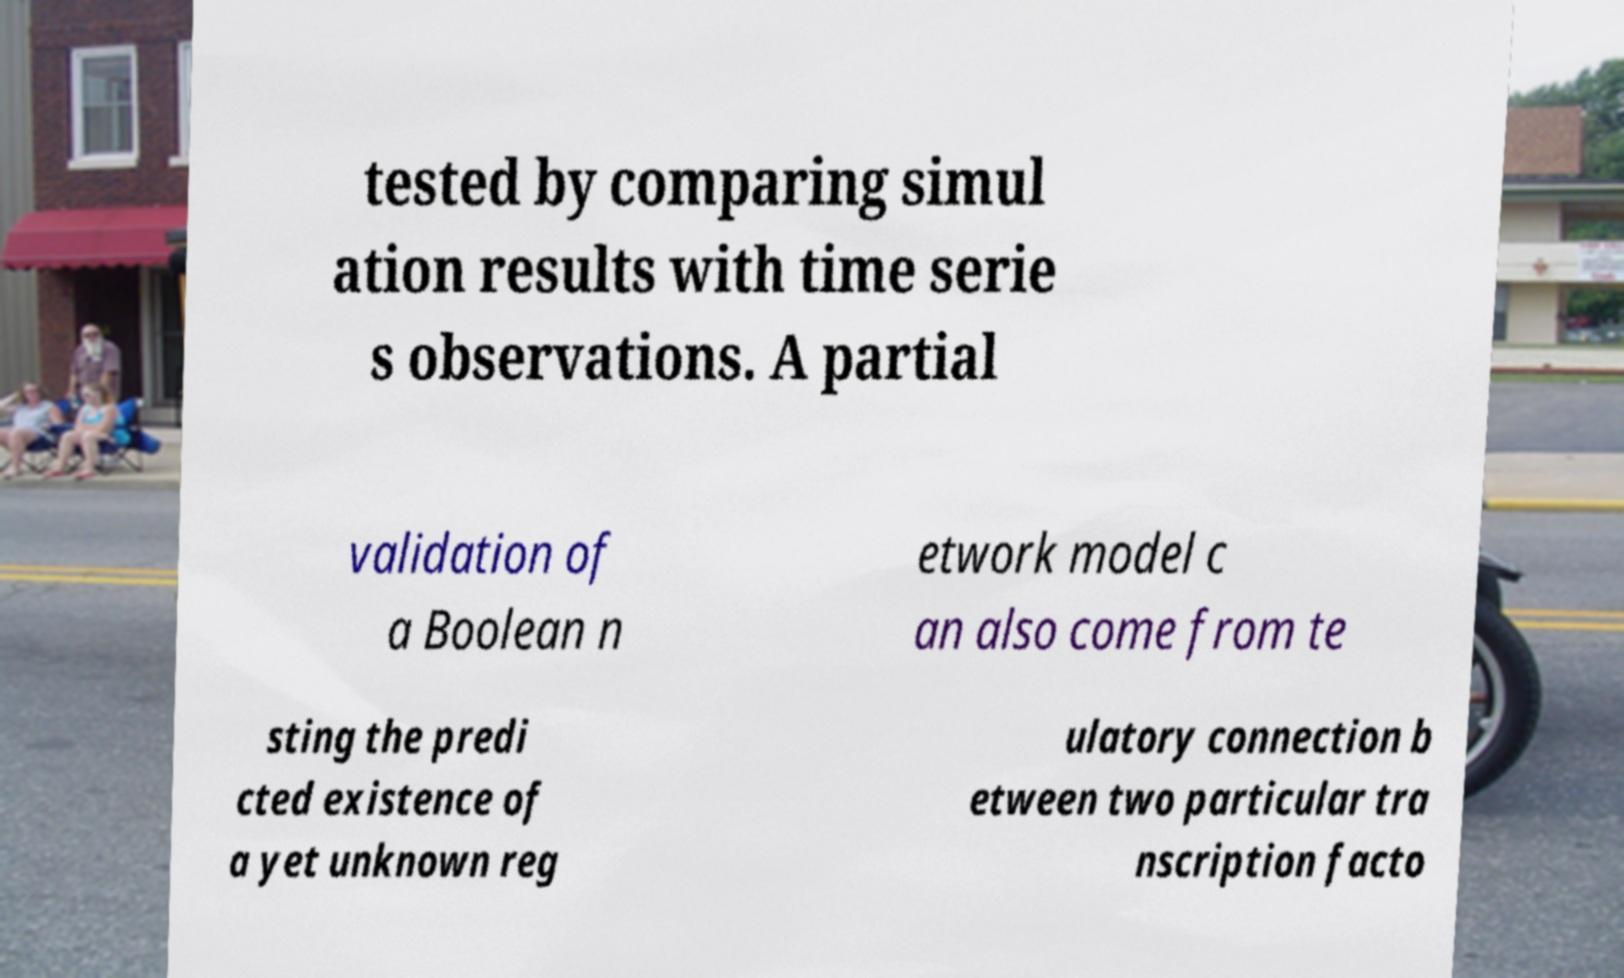Please identify and transcribe the text found in this image. tested by comparing simul ation results with time serie s observations. A partial validation of a Boolean n etwork model c an also come from te sting the predi cted existence of a yet unknown reg ulatory connection b etween two particular tra nscription facto 